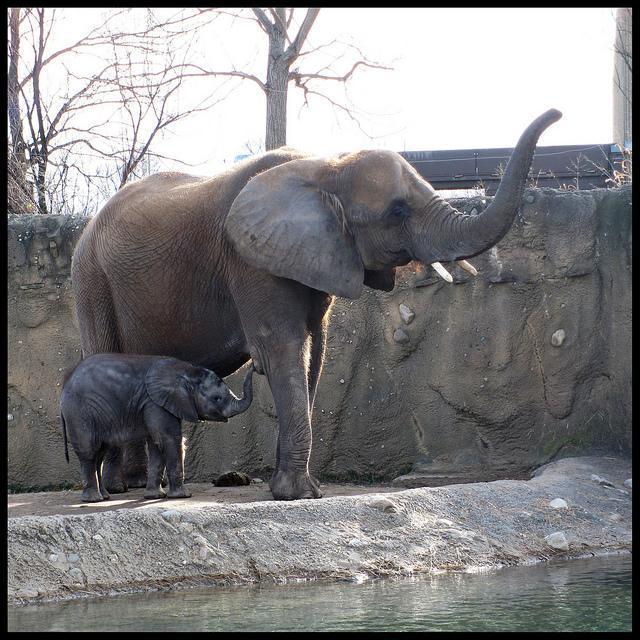How many elephants are in the photo?
Give a very brief answer. 2. How many boys are walking a white dog?
Give a very brief answer. 0. 